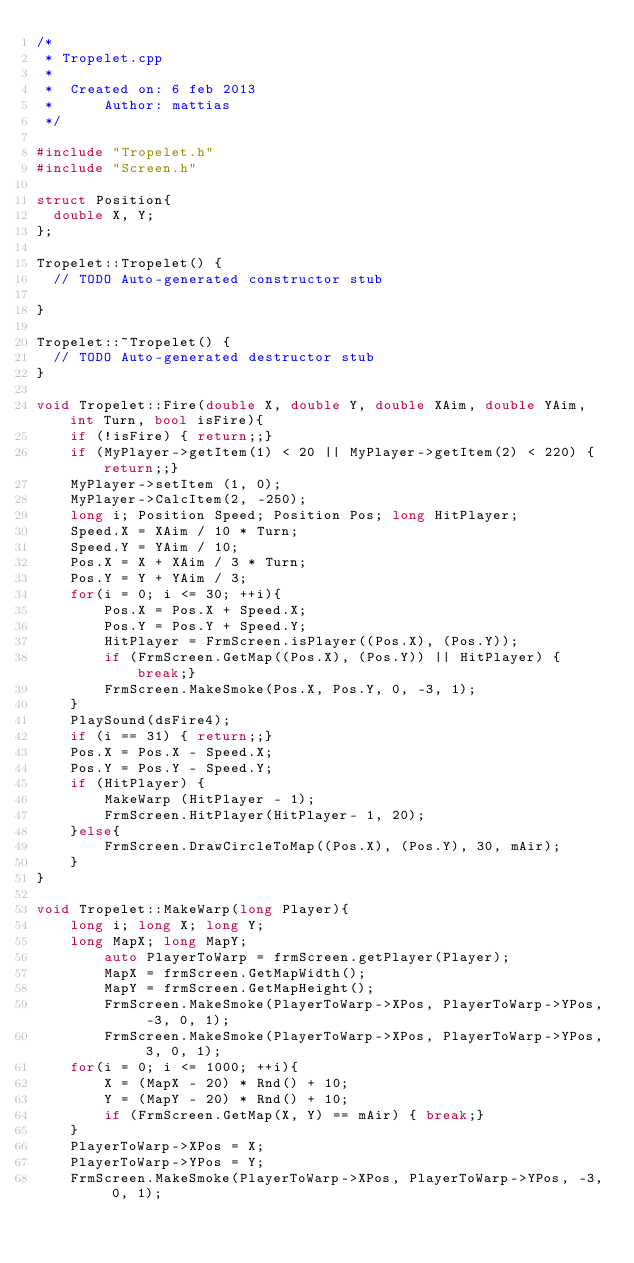<code> <loc_0><loc_0><loc_500><loc_500><_C++_>/*
 * Tropelet.cpp
 *
 *  Created on: 6 feb 2013
 *      Author: mattias
 */

#include "Tropelet.h"
#include "Screen.h"

struct Position{
	double X, Y;
};

Tropelet::Tropelet() {
	// TODO Auto-generated constructor stub

}

Tropelet::~Tropelet() {
	// TODO Auto-generated destructor stub
}

void Tropelet::Fire(double X, double Y, double XAim, double YAim, int Turn, bool isFire){
    if (!isFire) { return;;}
    if (MyPlayer->getItem(1) < 20 || MyPlayer->getItem(2) < 220) { return;;}
    MyPlayer->setItem (1, 0);
    MyPlayer->CalcItem(2, -250);
    long i; Position Speed; Position Pos; long HitPlayer;
    Speed.X = XAim / 10 * Turn;
    Speed.Y = YAim / 10;
    Pos.X = X + XAim / 3 * Turn;
    Pos.Y = Y + YAim / 3;
    for(i = 0; i <= 30; ++i){
        Pos.X = Pos.X + Speed.X;
        Pos.Y = Pos.Y + Speed.Y;
        HitPlayer = FrmScreen.isPlayer((Pos.X), (Pos.Y));
        if (FrmScreen.GetMap((Pos.X), (Pos.Y)) || HitPlayer) { break;}
        FrmScreen.MakeSmoke(Pos.X, Pos.Y, 0, -3, 1);
    }
    PlaySound(dsFire4);
    if (i == 31) { return;;}
    Pos.X = Pos.X - Speed.X;
    Pos.Y = Pos.Y - Speed.Y;
    if (HitPlayer) {
        MakeWarp (HitPlayer - 1);
        FrmScreen.HitPlayer(HitPlayer- 1, 20);
    }else{
        FrmScreen.DrawCircleToMap((Pos.X), (Pos.Y), 30, mAir);
    }
}

void Tropelet::MakeWarp(long Player){
    long i; long X; long Y;
    long MapX; long MapY;
        auto PlayerToWarp = frmScreen.getPlayer(Player);
        MapX = frmScreen.GetMapWidth();
        MapY = frmScreen.GetMapHeight();
        FrmScreen.MakeSmoke(PlayerToWarp->XPos, PlayerToWarp->YPos, -3, 0, 1);
        FrmScreen.MakeSmoke(PlayerToWarp->XPos, PlayerToWarp->YPos, 3, 0, 1);
    for(i = 0; i <= 1000; ++i){
        X = (MapX - 20) * Rnd() + 10;
        Y = (MapY - 20) * Rnd() + 10;
        if (FrmScreen.GetMap(X, Y) == mAir) { break;}
    }
    PlayerToWarp->XPos = X;
    PlayerToWarp->YPos = Y;
    FrmScreen.MakeSmoke(PlayerToWarp->XPos, PlayerToWarp->YPos, -3, 0, 1);</code> 